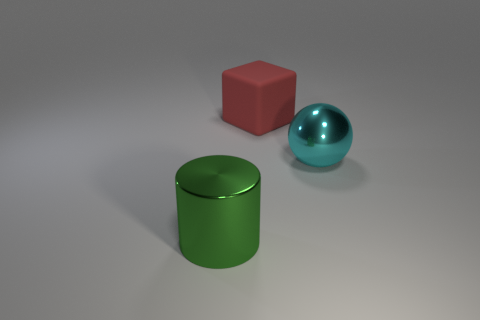Add 3 large balls. How many objects exist? 6 Subtract all spheres. How many objects are left? 2 Add 2 green shiny cylinders. How many green shiny cylinders are left? 3 Add 3 cyan things. How many cyan things exist? 4 Subtract 0 yellow cubes. How many objects are left? 3 Subtract all red cylinders. Subtract all cyan balls. How many cylinders are left? 1 Subtract all gray balls. How many red cylinders are left? 0 Subtract all cyan objects. Subtract all big green cylinders. How many objects are left? 1 